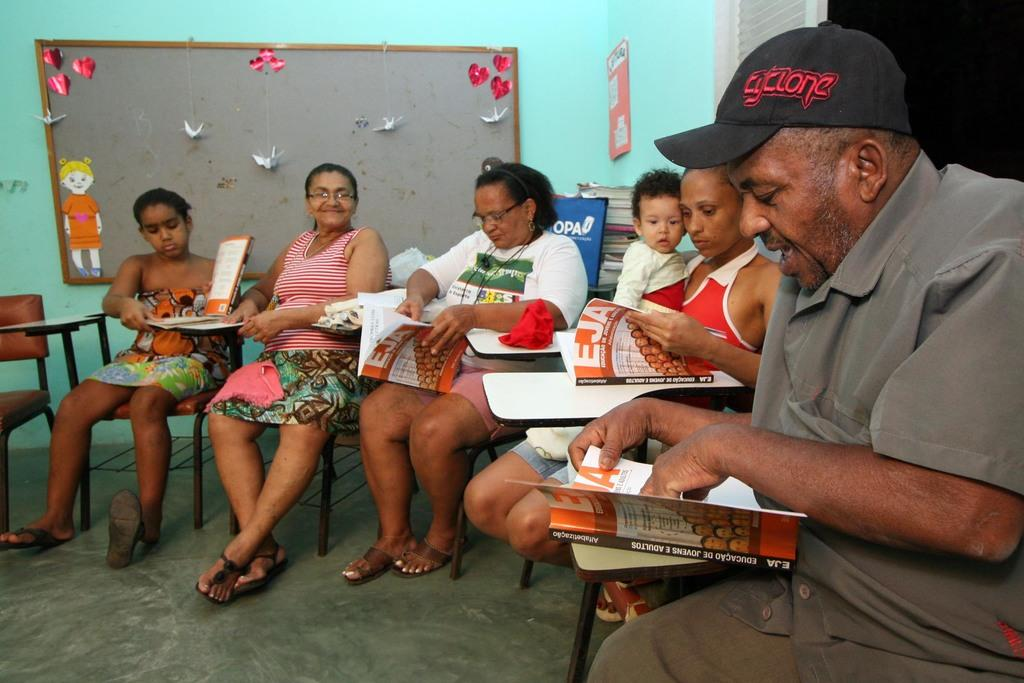What are the people in the image doing? The people in the image are sitting on chairs. What objects are the people holding in their hands? The people are holding books in their hands. What can be seen in the background of the image? There is a board and a paper placed on the wall in the background. What type of spoon is being used for a science experiment in the image? There is no spoon or science experiment present in the image. How many children are visible in the image? There is no mention of children in the provided facts, so we cannot determine the number of children in the image. 